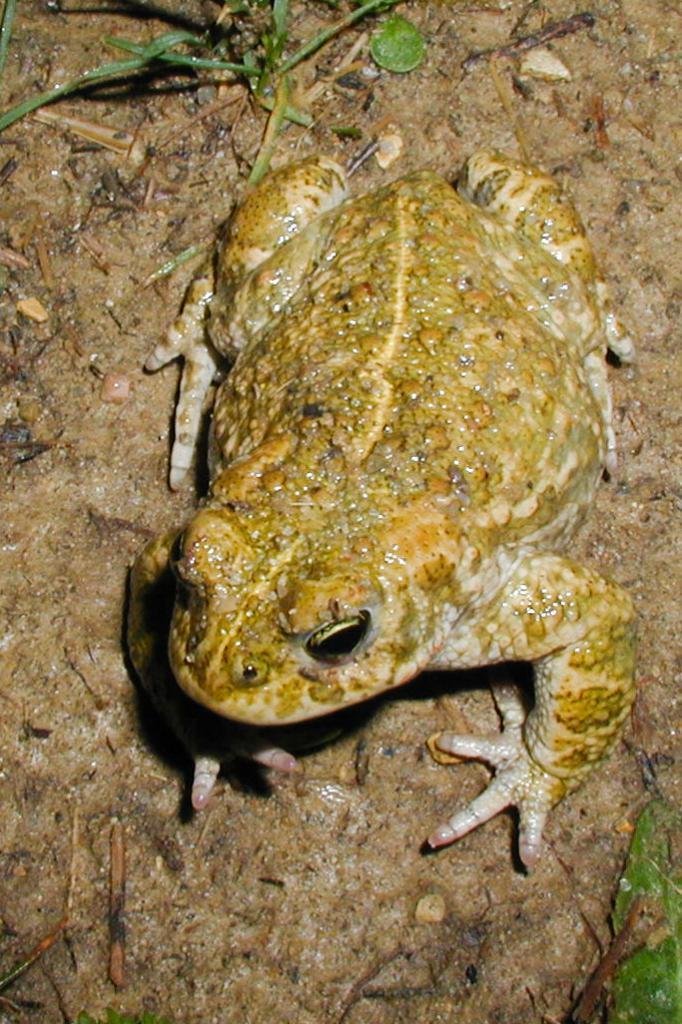Could you give a brief overview of what you see in this image? In this picture there is a frog. On the top we can see grass. On the bottom right corner there is a leaf. 